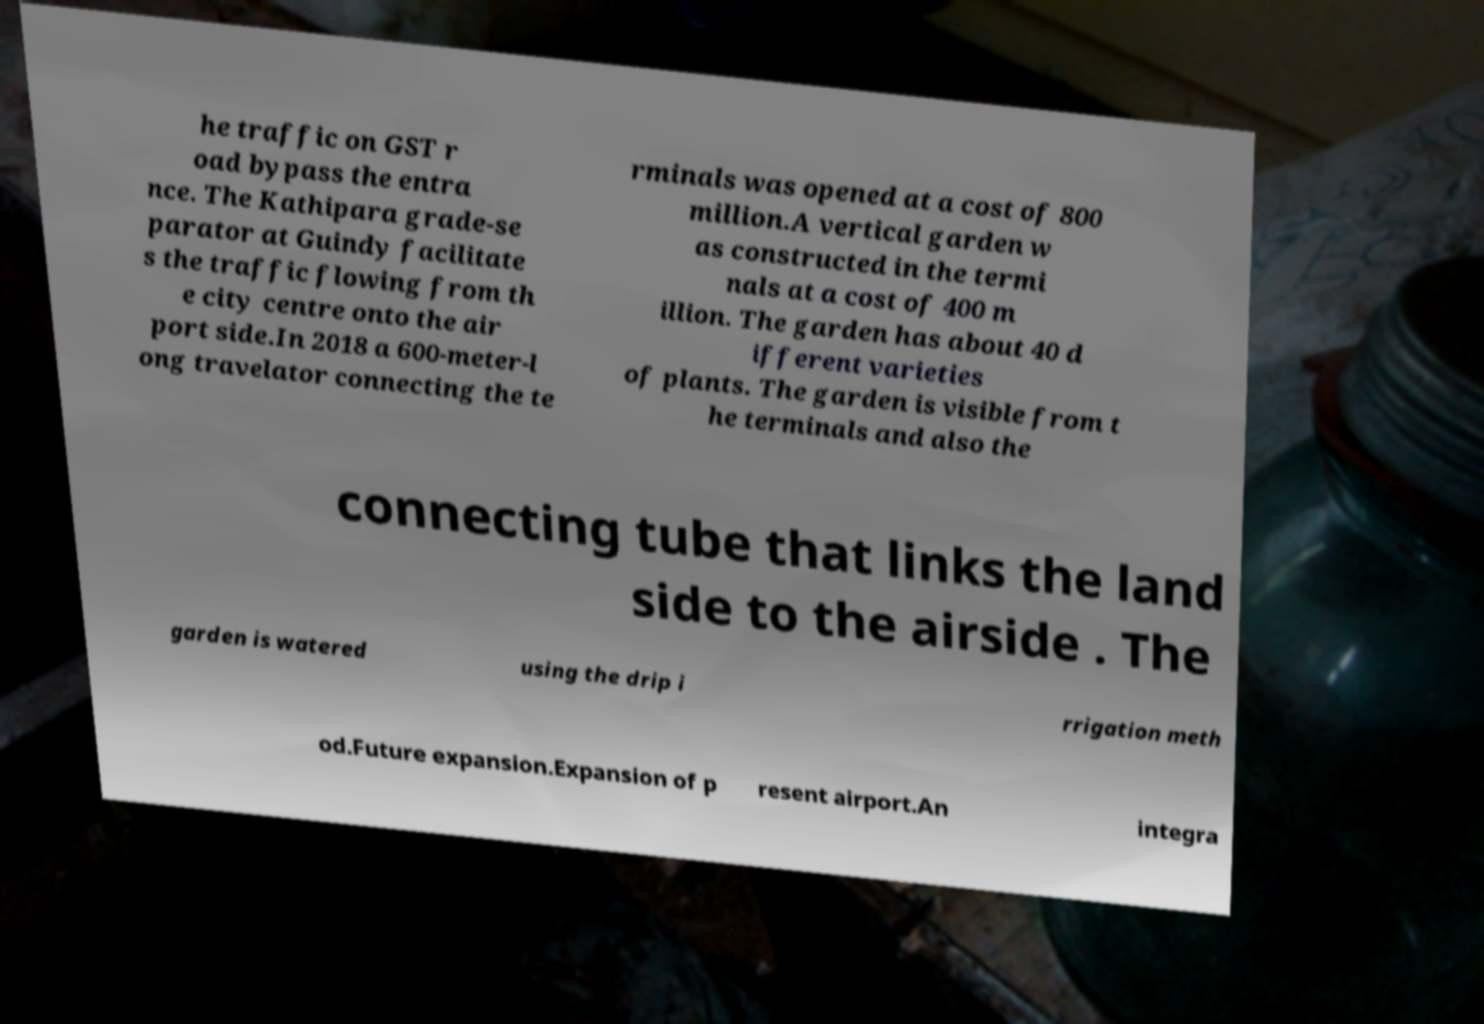I need the written content from this picture converted into text. Can you do that? he traffic on GST r oad bypass the entra nce. The Kathipara grade-se parator at Guindy facilitate s the traffic flowing from th e city centre onto the air port side.In 2018 a 600-meter-l ong travelator connecting the te rminals was opened at a cost of 800 million.A vertical garden w as constructed in the termi nals at a cost of 400 m illion. The garden has about 40 d ifferent varieties of plants. The garden is visible from t he terminals and also the connecting tube that links the land side to the airside . The garden is watered using the drip i rrigation meth od.Future expansion.Expansion of p resent airport.An integra 